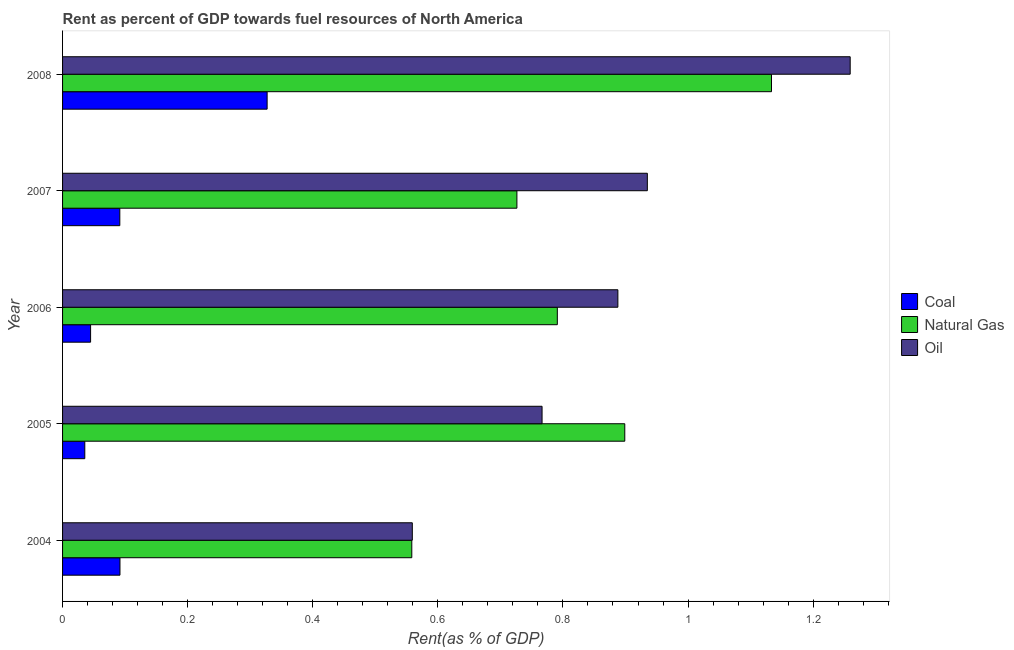How many different coloured bars are there?
Provide a succinct answer. 3. What is the rent towards natural gas in 2006?
Keep it short and to the point. 0.79. Across all years, what is the maximum rent towards natural gas?
Offer a terse response. 1.13. Across all years, what is the minimum rent towards coal?
Provide a succinct answer. 0.04. In which year was the rent towards coal maximum?
Make the answer very short. 2008. In which year was the rent towards oil minimum?
Make the answer very short. 2004. What is the total rent towards oil in the graph?
Ensure brevity in your answer.  4.41. What is the difference between the rent towards oil in 2004 and that in 2006?
Offer a terse response. -0.33. What is the difference between the rent towards natural gas in 2006 and the rent towards coal in 2007?
Give a very brief answer. 0.7. What is the average rent towards coal per year?
Offer a terse response. 0.12. In the year 2004, what is the difference between the rent towards natural gas and rent towards coal?
Provide a short and direct response. 0.47. In how many years, is the rent towards natural gas greater than 0.92 %?
Offer a very short reply. 1. What is the ratio of the rent towards coal in 2004 to that in 2005?
Ensure brevity in your answer.  2.58. What is the difference between the highest and the second highest rent towards coal?
Ensure brevity in your answer.  0.23. What is the difference between the highest and the lowest rent towards coal?
Your answer should be compact. 0.29. Is the sum of the rent towards natural gas in 2005 and 2006 greater than the maximum rent towards coal across all years?
Provide a succinct answer. Yes. What does the 1st bar from the top in 2005 represents?
Your answer should be compact. Oil. What does the 3rd bar from the bottom in 2007 represents?
Offer a very short reply. Oil. Is it the case that in every year, the sum of the rent towards coal and rent towards natural gas is greater than the rent towards oil?
Your answer should be compact. No. Are all the bars in the graph horizontal?
Provide a succinct answer. Yes. Does the graph contain any zero values?
Provide a short and direct response. No. How many legend labels are there?
Offer a very short reply. 3. What is the title of the graph?
Keep it short and to the point. Rent as percent of GDP towards fuel resources of North America. Does "Ages 15-64" appear as one of the legend labels in the graph?
Make the answer very short. No. What is the label or title of the X-axis?
Offer a terse response. Rent(as % of GDP). What is the label or title of the Y-axis?
Provide a succinct answer. Year. What is the Rent(as % of GDP) in Coal in 2004?
Offer a terse response. 0.09. What is the Rent(as % of GDP) of Natural Gas in 2004?
Make the answer very short. 0.56. What is the Rent(as % of GDP) of Oil in 2004?
Your answer should be very brief. 0.56. What is the Rent(as % of GDP) in Coal in 2005?
Your answer should be compact. 0.04. What is the Rent(as % of GDP) in Natural Gas in 2005?
Your answer should be very brief. 0.9. What is the Rent(as % of GDP) in Oil in 2005?
Your response must be concise. 0.77. What is the Rent(as % of GDP) of Coal in 2006?
Offer a very short reply. 0.04. What is the Rent(as % of GDP) in Natural Gas in 2006?
Your answer should be compact. 0.79. What is the Rent(as % of GDP) of Oil in 2006?
Ensure brevity in your answer.  0.89. What is the Rent(as % of GDP) of Coal in 2007?
Ensure brevity in your answer.  0.09. What is the Rent(as % of GDP) of Natural Gas in 2007?
Provide a short and direct response. 0.73. What is the Rent(as % of GDP) in Oil in 2007?
Make the answer very short. 0.93. What is the Rent(as % of GDP) in Coal in 2008?
Keep it short and to the point. 0.33. What is the Rent(as % of GDP) in Natural Gas in 2008?
Your response must be concise. 1.13. What is the Rent(as % of GDP) of Oil in 2008?
Provide a succinct answer. 1.26. Across all years, what is the maximum Rent(as % of GDP) of Coal?
Provide a short and direct response. 0.33. Across all years, what is the maximum Rent(as % of GDP) of Natural Gas?
Your answer should be very brief. 1.13. Across all years, what is the maximum Rent(as % of GDP) of Oil?
Keep it short and to the point. 1.26. Across all years, what is the minimum Rent(as % of GDP) of Coal?
Give a very brief answer. 0.04. Across all years, what is the minimum Rent(as % of GDP) in Natural Gas?
Provide a short and direct response. 0.56. Across all years, what is the minimum Rent(as % of GDP) of Oil?
Ensure brevity in your answer.  0.56. What is the total Rent(as % of GDP) in Coal in the graph?
Keep it short and to the point. 0.59. What is the total Rent(as % of GDP) of Natural Gas in the graph?
Make the answer very short. 4.11. What is the total Rent(as % of GDP) of Oil in the graph?
Your answer should be very brief. 4.41. What is the difference between the Rent(as % of GDP) of Coal in 2004 and that in 2005?
Make the answer very short. 0.06. What is the difference between the Rent(as % of GDP) in Natural Gas in 2004 and that in 2005?
Offer a terse response. -0.34. What is the difference between the Rent(as % of GDP) in Oil in 2004 and that in 2005?
Keep it short and to the point. -0.21. What is the difference between the Rent(as % of GDP) of Coal in 2004 and that in 2006?
Keep it short and to the point. 0.05. What is the difference between the Rent(as % of GDP) of Natural Gas in 2004 and that in 2006?
Provide a short and direct response. -0.23. What is the difference between the Rent(as % of GDP) of Oil in 2004 and that in 2006?
Your response must be concise. -0.33. What is the difference between the Rent(as % of GDP) of Coal in 2004 and that in 2007?
Your answer should be compact. 0. What is the difference between the Rent(as % of GDP) of Natural Gas in 2004 and that in 2007?
Ensure brevity in your answer.  -0.17. What is the difference between the Rent(as % of GDP) of Oil in 2004 and that in 2007?
Provide a short and direct response. -0.38. What is the difference between the Rent(as % of GDP) in Coal in 2004 and that in 2008?
Your answer should be compact. -0.24. What is the difference between the Rent(as % of GDP) of Natural Gas in 2004 and that in 2008?
Offer a very short reply. -0.58. What is the difference between the Rent(as % of GDP) in Oil in 2004 and that in 2008?
Provide a short and direct response. -0.7. What is the difference between the Rent(as % of GDP) in Coal in 2005 and that in 2006?
Provide a short and direct response. -0.01. What is the difference between the Rent(as % of GDP) in Natural Gas in 2005 and that in 2006?
Ensure brevity in your answer.  0.11. What is the difference between the Rent(as % of GDP) of Oil in 2005 and that in 2006?
Offer a very short reply. -0.12. What is the difference between the Rent(as % of GDP) of Coal in 2005 and that in 2007?
Offer a terse response. -0.06. What is the difference between the Rent(as % of GDP) in Natural Gas in 2005 and that in 2007?
Your response must be concise. 0.17. What is the difference between the Rent(as % of GDP) in Oil in 2005 and that in 2007?
Offer a terse response. -0.17. What is the difference between the Rent(as % of GDP) of Coal in 2005 and that in 2008?
Make the answer very short. -0.29. What is the difference between the Rent(as % of GDP) of Natural Gas in 2005 and that in 2008?
Your response must be concise. -0.23. What is the difference between the Rent(as % of GDP) of Oil in 2005 and that in 2008?
Your answer should be compact. -0.49. What is the difference between the Rent(as % of GDP) in Coal in 2006 and that in 2007?
Give a very brief answer. -0.05. What is the difference between the Rent(as % of GDP) in Natural Gas in 2006 and that in 2007?
Offer a terse response. 0.06. What is the difference between the Rent(as % of GDP) in Oil in 2006 and that in 2007?
Make the answer very short. -0.05. What is the difference between the Rent(as % of GDP) in Coal in 2006 and that in 2008?
Your answer should be very brief. -0.28. What is the difference between the Rent(as % of GDP) of Natural Gas in 2006 and that in 2008?
Your answer should be very brief. -0.34. What is the difference between the Rent(as % of GDP) of Oil in 2006 and that in 2008?
Keep it short and to the point. -0.37. What is the difference between the Rent(as % of GDP) in Coal in 2007 and that in 2008?
Offer a terse response. -0.24. What is the difference between the Rent(as % of GDP) in Natural Gas in 2007 and that in 2008?
Offer a very short reply. -0.41. What is the difference between the Rent(as % of GDP) of Oil in 2007 and that in 2008?
Give a very brief answer. -0.32. What is the difference between the Rent(as % of GDP) in Coal in 2004 and the Rent(as % of GDP) in Natural Gas in 2005?
Offer a terse response. -0.81. What is the difference between the Rent(as % of GDP) in Coal in 2004 and the Rent(as % of GDP) in Oil in 2005?
Provide a short and direct response. -0.67. What is the difference between the Rent(as % of GDP) in Natural Gas in 2004 and the Rent(as % of GDP) in Oil in 2005?
Your response must be concise. -0.21. What is the difference between the Rent(as % of GDP) in Coal in 2004 and the Rent(as % of GDP) in Natural Gas in 2006?
Offer a terse response. -0.7. What is the difference between the Rent(as % of GDP) of Coal in 2004 and the Rent(as % of GDP) of Oil in 2006?
Your response must be concise. -0.8. What is the difference between the Rent(as % of GDP) of Natural Gas in 2004 and the Rent(as % of GDP) of Oil in 2006?
Give a very brief answer. -0.33. What is the difference between the Rent(as % of GDP) of Coal in 2004 and the Rent(as % of GDP) of Natural Gas in 2007?
Give a very brief answer. -0.63. What is the difference between the Rent(as % of GDP) of Coal in 2004 and the Rent(as % of GDP) of Oil in 2007?
Ensure brevity in your answer.  -0.84. What is the difference between the Rent(as % of GDP) in Natural Gas in 2004 and the Rent(as % of GDP) in Oil in 2007?
Keep it short and to the point. -0.38. What is the difference between the Rent(as % of GDP) of Coal in 2004 and the Rent(as % of GDP) of Natural Gas in 2008?
Keep it short and to the point. -1.04. What is the difference between the Rent(as % of GDP) of Coal in 2004 and the Rent(as % of GDP) of Oil in 2008?
Your response must be concise. -1.17. What is the difference between the Rent(as % of GDP) in Natural Gas in 2004 and the Rent(as % of GDP) in Oil in 2008?
Provide a short and direct response. -0.7. What is the difference between the Rent(as % of GDP) in Coal in 2005 and the Rent(as % of GDP) in Natural Gas in 2006?
Your answer should be very brief. -0.76. What is the difference between the Rent(as % of GDP) of Coal in 2005 and the Rent(as % of GDP) of Oil in 2006?
Your answer should be very brief. -0.85. What is the difference between the Rent(as % of GDP) in Natural Gas in 2005 and the Rent(as % of GDP) in Oil in 2006?
Your answer should be very brief. 0.01. What is the difference between the Rent(as % of GDP) in Coal in 2005 and the Rent(as % of GDP) in Natural Gas in 2007?
Offer a very short reply. -0.69. What is the difference between the Rent(as % of GDP) of Coal in 2005 and the Rent(as % of GDP) of Oil in 2007?
Your response must be concise. -0.9. What is the difference between the Rent(as % of GDP) in Natural Gas in 2005 and the Rent(as % of GDP) in Oil in 2007?
Provide a short and direct response. -0.04. What is the difference between the Rent(as % of GDP) in Coal in 2005 and the Rent(as % of GDP) in Natural Gas in 2008?
Your answer should be very brief. -1.1. What is the difference between the Rent(as % of GDP) of Coal in 2005 and the Rent(as % of GDP) of Oil in 2008?
Offer a terse response. -1.22. What is the difference between the Rent(as % of GDP) in Natural Gas in 2005 and the Rent(as % of GDP) in Oil in 2008?
Your answer should be compact. -0.36. What is the difference between the Rent(as % of GDP) of Coal in 2006 and the Rent(as % of GDP) of Natural Gas in 2007?
Your response must be concise. -0.68. What is the difference between the Rent(as % of GDP) of Coal in 2006 and the Rent(as % of GDP) of Oil in 2007?
Offer a very short reply. -0.89. What is the difference between the Rent(as % of GDP) in Natural Gas in 2006 and the Rent(as % of GDP) in Oil in 2007?
Ensure brevity in your answer.  -0.14. What is the difference between the Rent(as % of GDP) in Coal in 2006 and the Rent(as % of GDP) in Natural Gas in 2008?
Make the answer very short. -1.09. What is the difference between the Rent(as % of GDP) of Coal in 2006 and the Rent(as % of GDP) of Oil in 2008?
Your answer should be very brief. -1.21. What is the difference between the Rent(as % of GDP) in Natural Gas in 2006 and the Rent(as % of GDP) in Oil in 2008?
Offer a very short reply. -0.47. What is the difference between the Rent(as % of GDP) in Coal in 2007 and the Rent(as % of GDP) in Natural Gas in 2008?
Keep it short and to the point. -1.04. What is the difference between the Rent(as % of GDP) in Coal in 2007 and the Rent(as % of GDP) in Oil in 2008?
Your answer should be very brief. -1.17. What is the difference between the Rent(as % of GDP) of Natural Gas in 2007 and the Rent(as % of GDP) of Oil in 2008?
Give a very brief answer. -0.53. What is the average Rent(as % of GDP) of Coal per year?
Make the answer very short. 0.12. What is the average Rent(as % of GDP) of Natural Gas per year?
Give a very brief answer. 0.82. What is the average Rent(as % of GDP) of Oil per year?
Your answer should be compact. 0.88. In the year 2004, what is the difference between the Rent(as % of GDP) of Coal and Rent(as % of GDP) of Natural Gas?
Ensure brevity in your answer.  -0.47. In the year 2004, what is the difference between the Rent(as % of GDP) of Coal and Rent(as % of GDP) of Oil?
Offer a very short reply. -0.47. In the year 2004, what is the difference between the Rent(as % of GDP) in Natural Gas and Rent(as % of GDP) in Oil?
Provide a succinct answer. -0. In the year 2005, what is the difference between the Rent(as % of GDP) of Coal and Rent(as % of GDP) of Natural Gas?
Provide a succinct answer. -0.86. In the year 2005, what is the difference between the Rent(as % of GDP) in Coal and Rent(as % of GDP) in Oil?
Ensure brevity in your answer.  -0.73. In the year 2005, what is the difference between the Rent(as % of GDP) in Natural Gas and Rent(as % of GDP) in Oil?
Your response must be concise. 0.13. In the year 2006, what is the difference between the Rent(as % of GDP) in Coal and Rent(as % of GDP) in Natural Gas?
Provide a short and direct response. -0.75. In the year 2006, what is the difference between the Rent(as % of GDP) of Coal and Rent(as % of GDP) of Oil?
Provide a succinct answer. -0.84. In the year 2006, what is the difference between the Rent(as % of GDP) of Natural Gas and Rent(as % of GDP) of Oil?
Your answer should be compact. -0.1. In the year 2007, what is the difference between the Rent(as % of GDP) of Coal and Rent(as % of GDP) of Natural Gas?
Keep it short and to the point. -0.63. In the year 2007, what is the difference between the Rent(as % of GDP) in Coal and Rent(as % of GDP) in Oil?
Keep it short and to the point. -0.84. In the year 2007, what is the difference between the Rent(as % of GDP) of Natural Gas and Rent(as % of GDP) of Oil?
Offer a very short reply. -0.21. In the year 2008, what is the difference between the Rent(as % of GDP) of Coal and Rent(as % of GDP) of Natural Gas?
Your answer should be compact. -0.81. In the year 2008, what is the difference between the Rent(as % of GDP) of Coal and Rent(as % of GDP) of Oil?
Offer a terse response. -0.93. In the year 2008, what is the difference between the Rent(as % of GDP) in Natural Gas and Rent(as % of GDP) in Oil?
Provide a succinct answer. -0.13. What is the ratio of the Rent(as % of GDP) in Coal in 2004 to that in 2005?
Give a very brief answer. 2.58. What is the ratio of the Rent(as % of GDP) of Natural Gas in 2004 to that in 2005?
Give a very brief answer. 0.62. What is the ratio of the Rent(as % of GDP) of Oil in 2004 to that in 2005?
Your answer should be compact. 0.73. What is the ratio of the Rent(as % of GDP) of Coal in 2004 to that in 2006?
Provide a short and direct response. 2.05. What is the ratio of the Rent(as % of GDP) of Natural Gas in 2004 to that in 2006?
Keep it short and to the point. 0.71. What is the ratio of the Rent(as % of GDP) in Oil in 2004 to that in 2006?
Your answer should be compact. 0.63. What is the ratio of the Rent(as % of GDP) in Natural Gas in 2004 to that in 2007?
Your answer should be very brief. 0.77. What is the ratio of the Rent(as % of GDP) in Oil in 2004 to that in 2007?
Your answer should be very brief. 0.6. What is the ratio of the Rent(as % of GDP) in Coal in 2004 to that in 2008?
Your answer should be compact. 0.28. What is the ratio of the Rent(as % of GDP) of Natural Gas in 2004 to that in 2008?
Your answer should be very brief. 0.49. What is the ratio of the Rent(as % of GDP) of Oil in 2004 to that in 2008?
Give a very brief answer. 0.44. What is the ratio of the Rent(as % of GDP) in Coal in 2005 to that in 2006?
Offer a terse response. 0.79. What is the ratio of the Rent(as % of GDP) of Natural Gas in 2005 to that in 2006?
Make the answer very short. 1.14. What is the ratio of the Rent(as % of GDP) of Oil in 2005 to that in 2006?
Give a very brief answer. 0.86. What is the ratio of the Rent(as % of GDP) in Coal in 2005 to that in 2007?
Your answer should be compact. 0.39. What is the ratio of the Rent(as % of GDP) of Natural Gas in 2005 to that in 2007?
Provide a short and direct response. 1.24. What is the ratio of the Rent(as % of GDP) of Oil in 2005 to that in 2007?
Provide a short and direct response. 0.82. What is the ratio of the Rent(as % of GDP) of Coal in 2005 to that in 2008?
Provide a succinct answer. 0.11. What is the ratio of the Rent(as % of GDP) in Natural Gas in 2005 to that in 2008?
Your answer should be compact. 0.79. What is the ratio of the Rent(as % of GDP) in Oil in 2005 to that in 2008?
Make the answer very short. 0.61. What is the ratio of the Rent(as % of GDP) in Coal in 2006 to that in 2007?
Provide a short and direct response. 0.49. What is the ratio of the Rent(as % of GDP) in Natural Gas in 2006 to that in 2007?
Keep it short and to the point. 1.09. What is the ratio of the Rent(as % of GDP) of Oil in 2006 to that in 2007?
Offer a very short reply. 0.95. What is the ratio of the Rent(as % of GDP) of Coal in 2006 to that in 2008?
Ensure brevity in your answer.  0.14. What is the ratio of the Rent(as % of GDP) in Natural Gas in 2006 to that in 2008?
Ensure brevity in your answer.  0.7. What is the ratio of the Rent(as % of GDP) of Oil in 2006 to that in 2008?
Offer a very short reply. 0.7. What is the ratio of the Rent(as % of GDP) in Coal in 2007 to that in 2008?
Your response must be concise. 0.28. What is the ratio of the Rent(as % of GDP) of Natural Gas in 2007 to that in 2008?
Ensure brevity in your answer.  0.64. What is the ratio of the Rent(as % of GDP) in Oil in 2007 to that in 2008?
Offer a very short reply. 0.74. What is the difference between the highest and the second highest Rent(as % of GDP) of Coal?
Keep it short and to the point. 0.24. What is the difference between the highest and the second highest Rent(as % of GDP) of Natural Gas?
Ensure brevity in your answer.  0.23. What is the difference between the highest and the second highest Rent(as % of GDP) of Oil?
Your answer should be compact. 0.32. What is the difference between the highest and the lowest Rent(as % of GDP) in Coal?
Provide a short and direct response. 0.29. What is the difference between the highest and the lowest Rent(as % of GDP) of Natural Gas?
Offer a very short reply. 0.58. What is the difference between the highest and the lowest Rent(as % of GDP) in Oil?
Provide a short and direct response. 0.7. 